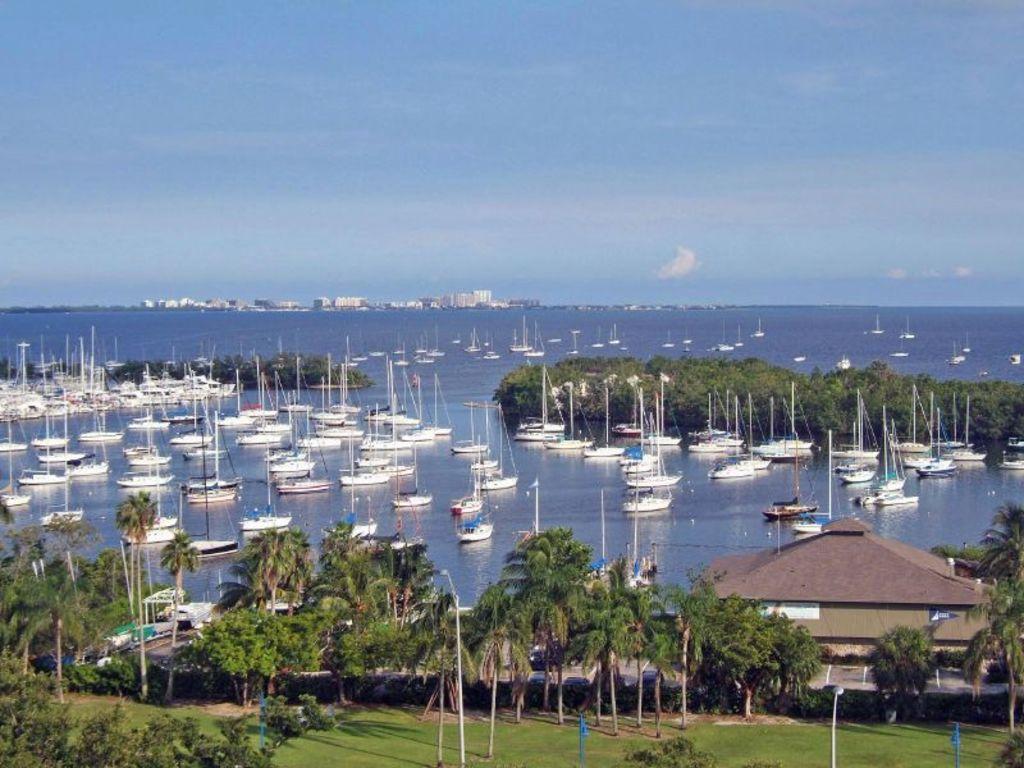Describe this image in one or two sentences. In this image there is water in the middle. In the water there are so many boats. At the bottom there is land on which there are trees. In the middle there is a house. At the top there is the sky. 